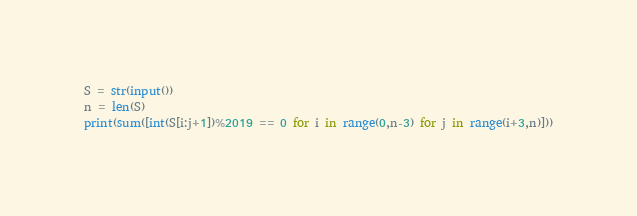<code> <loc_0><loc_0><loc_500><loc_500><_Python_>S = str(input())
n = len(S)
print(sum([int(S[i:j+1])%2019 == 0 for i in range(0,n-3) for j in range(i+3,n)]))</code> 